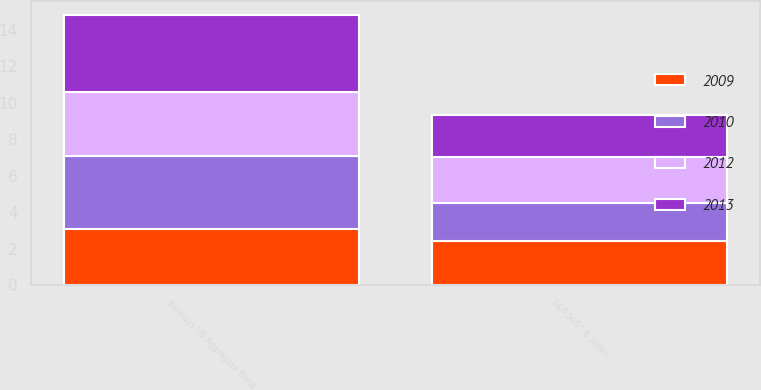Convert chart. <chart><loc_0><loc_0><loc_500><loc_500><stacked_bar_chart><ecel><fcel>Barclays US Aggregate Bond<fcel>S&P 500^® Index<nl><fcel>2009<fcel>3.1<fcel>2.4<nl><fcel>2012<fcel>3.5<fcel>2.5<nl><fcel>2010<fcel>4<fcel>2.1<nl><fcel>2013<fcel>4.2<fcel>2.3<nl></chart> 